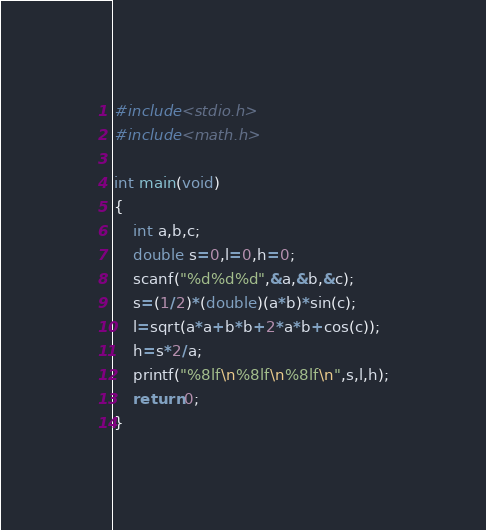<code> <loc_0><loc_0><loc_500><loc_500><_C++_>#include<stdio.h>
#include<math.h>

int main(void)
{
	int a,b,c;
	double s=0,l=0,h=0;
	scanf("%d%d%d",&a,&b,&c);
	s=(1/2)*(double)(a*b)*sin(c);
	l=sqrt(a*a+b*b+2*a*b+cos(c));
	h=s*2/a;
	printf("%8lf\n%8lf\n%8lf\n",s,l,h);
    return 0;
}</code> 